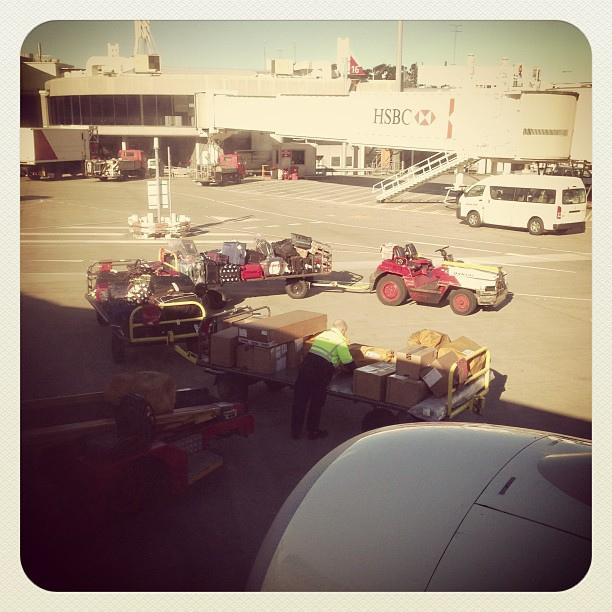What is the big item in the far back right?

Choices:
A) baseball stadium
B) statue
C) elephant
D) van van 